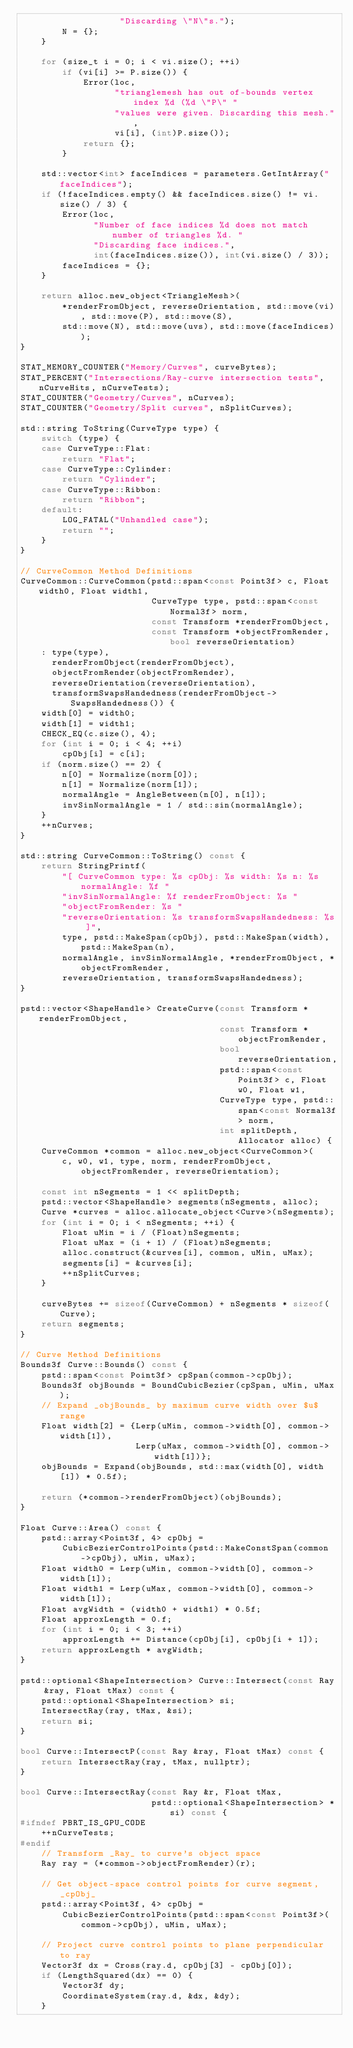Convert code to text. <code><loc_0><loc_0><loc_500><loc_500><_C++_>                   "Discarding \"N\"s.");
        N = {};
    }

    for (size_t i = 0; i < vi.size(); ++i)
        if (vi[i] >= P.size()) {
            Error(loc,
                  "trianglemesh has out of-bounds vertex index %d (%d \"P\" "
                  "values were given. Discarding this mesh.",
                  vi[i], (int)P.size());
            return {};
        }

    std::vector<int> faceIndices = parameters.GetIntArray("faceIndices");
    if (!faceIndices.empty() && faceIndices.size() != vi.size() / 3) {
        Error(loc,
              "Number of face indices %d does not match number of triangles %d. "
              "Discarding face indices.",
              int(faceIndices.size()), int(vi.size() / 3));
        faceIndices = {};
    }

    return alloc.new_object<TriangleMesh>(
        *renderFromObject, reverseOrientation, std::move(vi), std::move(P), std::move(S),
        std::move(N), std::move(uvs), std::move(faceIndices));
}

STAT_MEMORY_COUNTER("Memory/Curves", curveBytes);
STAT_PERCENT("Intersections/Ray-curve intersection tests", nCurveHits, nCurveTests);
STAT_COUNTER("Geometry/Curves", nCurves);
STAT_COUNTER("Geometry/Split curves", nSplitCurves);

std::string ToString(CurveType type) {
    switch (type) {
    case CurveType::Flat:
        return "Flat";
    case CurveType::Cylinder:
        return "Cylinder";
    case CurveType::Ribbon:
        return "Ribbon";
    default:
        LOG_FATAL("Unhandled case");
        return "";
    }
}

// CurveCommon Method Definitions
CurveCommon::CurveCommon(pstd::span<const Point3f> c, Float width0, Float width1,
                         CurveType type, pstd::span<const Normal3f> norm,
                         const Transform *renderFromObject,
                         const Transform *objectFromRender, bool reverseOrientation)
    : type(type),
      renderFromObject(renderFromObject),
      objectFromRender(objectFromRender),
      reverseOrientation(reverseOrientation),
      transformSwapsHandedness(renderFromObject->SwapsHandedness()) {
    width[0] = width0;
    width[1] = width1;
    CHECK_EQ(c.size(), 4);
    for (int i = 0; i < 4; ++i)
        cpObj[i] = c[i];
    if (norm.size() == 2) {
        n[0] = Normalize(norm[0]);
        n[1] = Normalize(norm[1]);
        normalAngle = AngleBetween(n[0], n[1]);
        invSinNormalAngle = 1 / std::sin(normalAngle);
    }
    ++nCurves;
}

std::string CurveCommon::ToString() const {
    return StringPrintf(
        "[ CurveCommon type: %s cpObj: %s width: %s n: %s normalAngle: %f "
        "invSinNormalAngle: %f renderFromObject: %s "
        "objectFromRender: %s "
        "reverseOrientation: %s transformSwapsHandedness: %s ]",
        type, pstd::MakeSpan(cpObj), pstd::MakeSpan(width), pstd::MakeSpan(n),
        normalAngle, invSinNormalAngle, *renderFromObject, *objectFromRender,
        reverseOrientation, transformSwapsHandedness);
}

pstd::vector<ShapeHandle> CreateCurve(const Transform *renderFromObject,
                                      const Transform *objectFromRender,
                                      bool reverseOrientation,
                                      pstd::span<const Point3f> c, Float w0, Float w1,
                                      CurveType type, pstd::span<const Normal3f> norm,
                                      int splitDepth, Allocator alloc) {
    CurveCommon *common = alloc.new_object<CurveCommon>(
        c, w0, w1, type, norm, renderFromObject, objectFromRender, reverseOrientation);

    const int nSegments = 1 << splitDepth;
    pstd::vector<ShapeHandle> segments(nSegments, alloc);
    Curve *curves = alloc.allocate_object<Curve>(nSegments);
    for (int i = 0; i < nSegments; ++i) {
        Float uMin = i / (Float)nSegments;
        Float uMax = (i + 1) / (Float)nSegments;
        alloc.construct(&curves[i], common, uMin, uMax);
        segments[i] = &curves[i];
        ++nSplitCurves;
    }

    curveBytes += sizeof(CurveCommon) + nSegments * sizeof(Curve);
    return segments;
}

// Curve Method Definitions
Bounds3f Curve::Bounds() const {
    pstd::span<const Point3f> cpSpan(common->cpObj);
    Bounds3f objBounds = BoundCubicBezier(cpSpan, uMin, uMax);
    // Expand _objBounds_ by maximum curve width over $u$ range
    Float width[2] = {Lerp(uMin, common->width[0], common->width[1]),
                      Lerp(uMax, common->width[0], common->width[1])};
    objBounds = Expand(objBounds, std::max(width[0], width[1]) * 0.5f);

    return (*common->renderFromObject)(objBounds);
}

Float Curve::Area() const {
    pstd::array<Point3f, 4> cpObj =
        CubicBezierControlPoints(pstd::MakeConstSpan(common->cpObj), uMin, uMax);
    Float width0 = Lerp(uMin, common->width[0], common->width[1]);
    Float width1 = Lerp(uMax, common->width[0], common->width[1]);
    Float avgWidth = (width0 + width1) * 0.5f;
    Float approxLength = 0.f;
    for (int i = 0; i < 3; ++i)
        approxLength += Distance(cpObj[i], cpObj[i + 1]);
    return approxLength * avgWidth;
}

pstd::optional<ShapeIntersection> Curve::Intersect(const Ray &ray, Float tMax) const {
    pstd::optional<ShapeIntersection> si;
    IntersectRay(ray, tMax, &si);
    return si;
}

bool Curve::IntersectP(const Ray &ray, Float tMax) const {
    return IntersectRay(ray, tMax, nullptr);
}

bool Curve::IntersectRay(const Ray &r, Float tMax,
                         pstd::optional<ShapeIntersection> *si) const {
#ifndef PBRT_IS_GPU_CODE
    ++nCurveTests;
#endif
    // Transform _Ray_ to curve's object space
    Ray ray = (*common->objectFromRender)(r);

    // Get object-space control points for curve segment, _cpObj_
    pstd::array<Point3f, 4> cpObj =
        CubicBezierControlPoints(pstd::span<const Point3f>(common->cpObj), uMin, uMax);

    // Project curve control points to plane perpendicular to ray
    Vector3f dx = Cross(ray.d, cpObj[3] - cpObj[0]);
    if (LengthSquared(dx) == 0) {
        Vector3f dy;
        CoordinateSystem(ray.d, &dx, &dy);
    }</code> 